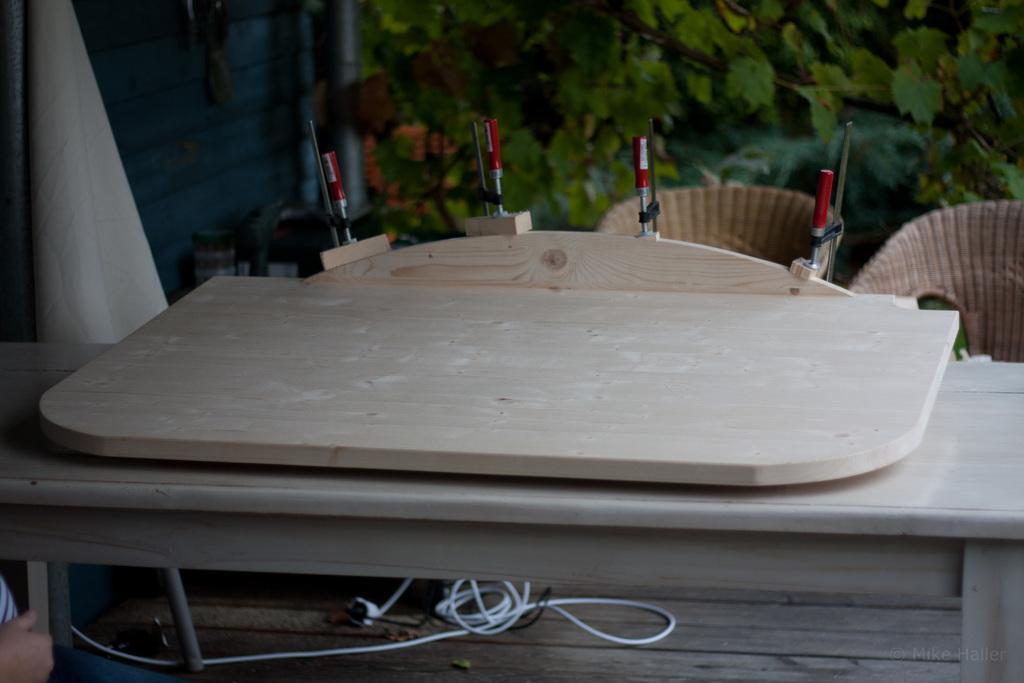Describe this image in one or two sentences. In the image in the center we can see one table. On table,we can see one wooden object. Below the table,we can see wooden floor,wires and one person hand. In the background we can see chairs,glass,trees,curtain and few other objects. 